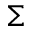Convert formula to latex. <formula><loc_0><loc_0><loc_500><loc_500>\Sigma</formula> 